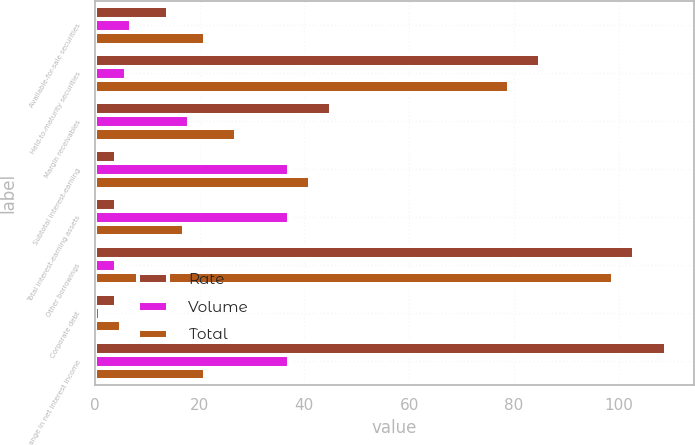Convert chart to OTSL. <chart><loc_0><loc_0><loc_500><loc_500><stacked_bar_chart><ecel><fcel>Available-for-sale securities<fcel>Held-to-maturity securities<fcel>Margin receivables<fcel>Subtotal interest-earning<fcel>Total interest-earning assets<fcel>Other borrowings<fcel>Corporate debt<fcel>Change in net interest income<nl><fcel>Rate<fcel>14<fcel>85<fcel>45<fcel>4<fcel>4<fcel>103<fcel>4<fcel>109<nl><fcel>Volume<fcel>7<fcel>6<fcel>18<fcel>37<fcel>37<fcel>4<fcel>1<fcel>37<nl><fcel>Total<fcel>21<fcel>79<fcel>27<fcel>41<fcel>17<fcel>99<fcel>5<fcel>21<nl></chart> 